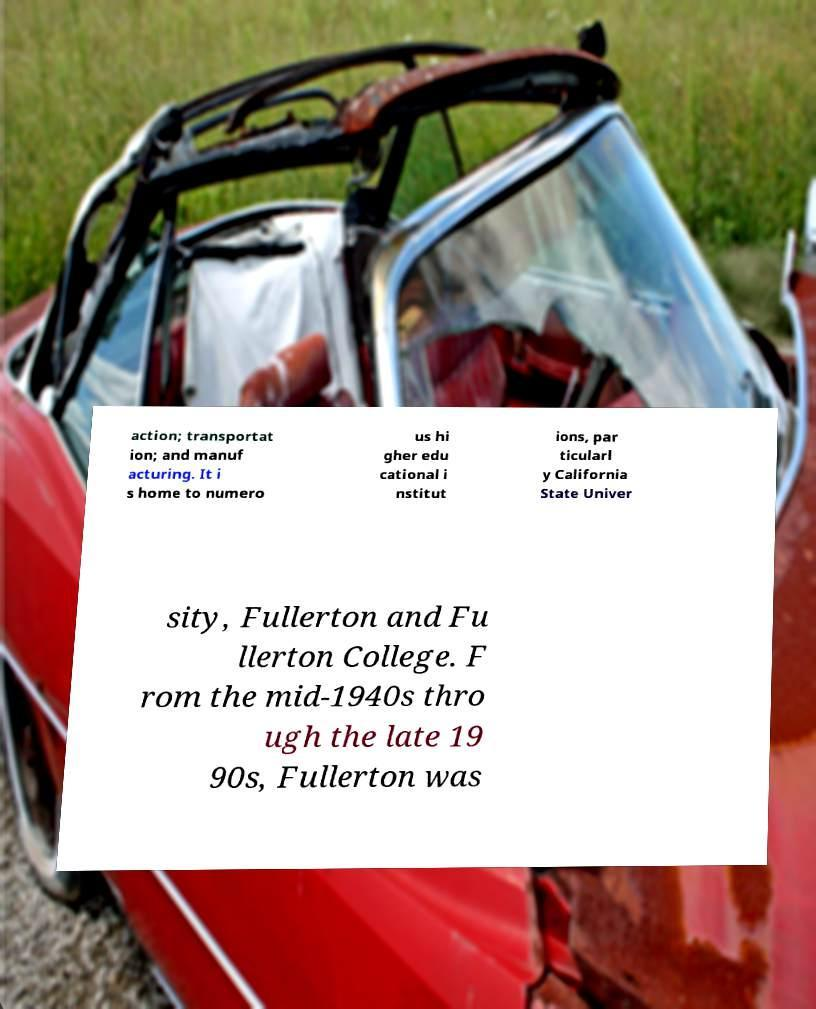Could you assist in decoding the text presented in this image and type it out clearly? action; transportat ion; and manuf acturing. It i s home to numero us hi gher edu cational i nstitut ions, par ticularl y California State Univer sity, Fullerton and Fu llerton College. F rom the mid-1940s thro ugh the late 19 90s, Fullerton was 